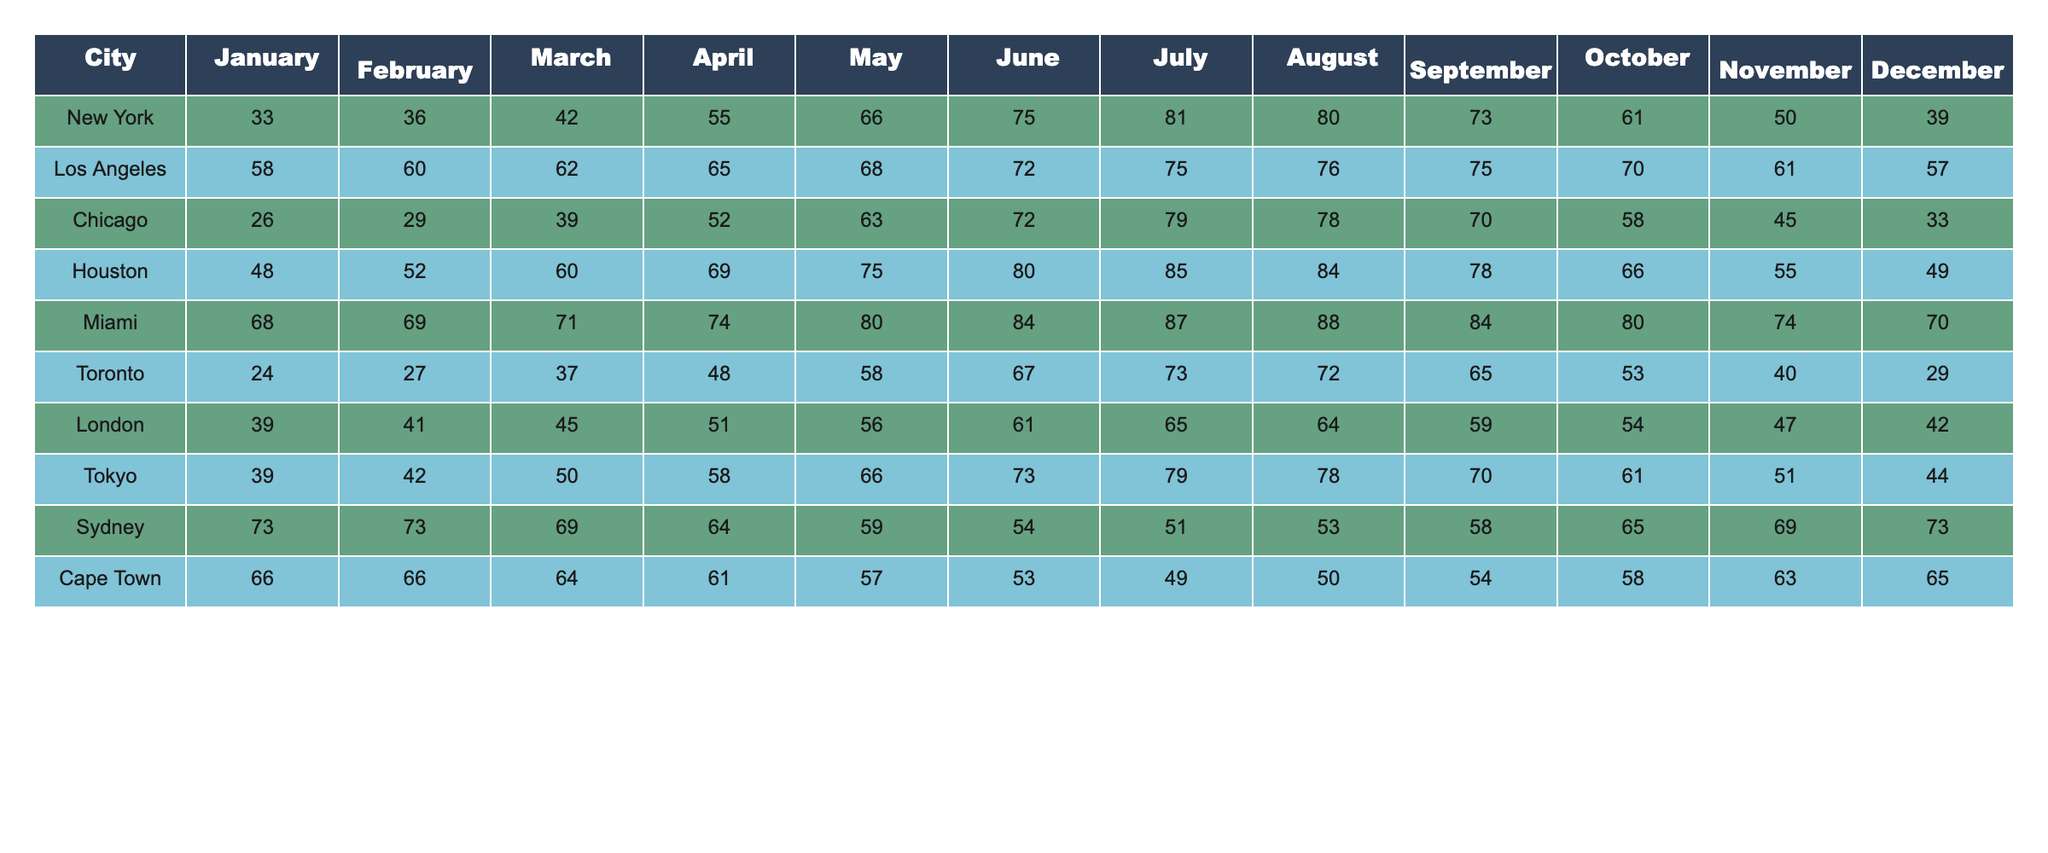What is the highest monthly average temperature recorded in Miami? By checking the temperatures listed for each month in Miami, July shows the highest value at 87 degrees.
Answer: 87 Which city has the lowest average temperature in January? Looking at the January temperatures, Chicago has the lowest at 26 degrees.
Answer: Chicago What is the average temperature in Los Angeles for the summer months (June, July, August)? The summer months' temperatures for Los Angeles are 72, 75, and 76. Calculating the average: (72 + 75 + 76) / 3 = 241 / 3 = 80.33, rounding gives us 80.
Answer: 80 True or False: Toronto's average temperature in December is higher than London’s. Checking December averages, Toronto has 29 degrees and London has 42 degrees; since 29 is less than 42, the answer is false.
Answer: False What is the difference between the highest and lowest average monthly temperature in Chicago? Chicago's highest average temperature is in July at 79 degrees and the lowest is in January at 26 degrees. The difference is 79 - 26 = 53 degrees.
Answer: 53 Which city experiences the highest average temperature in July? By examining July temperatures, Houston has the highest at 85 degrees, more than any other city listed.
Answer: Houston How does the average temperature in Sydney in December compare to that in New York? In December, Sydney has an average of 73 degrees while New York has 39 degrees. 73 is significantly higher than 39, indicating Sydney's December is warmer.
Answer: Sydney is warmer What are the three coldest months for Toronto, and what are their average temperatures? The temperatures for Toronto in January, February, and December are 24, 27, and 29 degrees respectively; these are the lowest temperatures.
Answer: 24, 27, 29 In which month does Chicago experience a temperature of 39 degrees? Checking the monthly temperatures in Chicago confirms that March has an average temperature of 39 degrees.
Answer: March What is the average temperature for Cape Town across all months, rounded to the nearest whole number? Adding up all of Cape Town's monthly temperatures: (66 + 66 + 64 + 61 + 57 + 53 + 49 + 50 + 54 + 58 + 63 + 65) =  55.5 and dividing by 12 gives 55, rounding leads to 55 degrees.
Answer: 55 